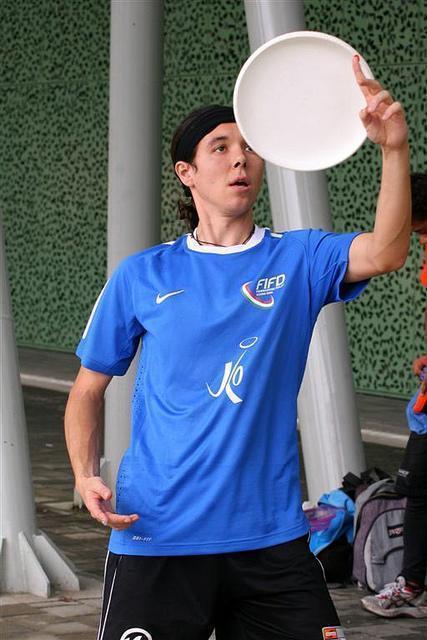What is he doing with the frisbee?
Select the accurate answer and provide justification: `Answer: choice
Rationale: srationale.`
Options: Holding it, throwing it, balancing it, twirling it. Answer: balancing it.
Rationale: He is balancing it on his finger. 